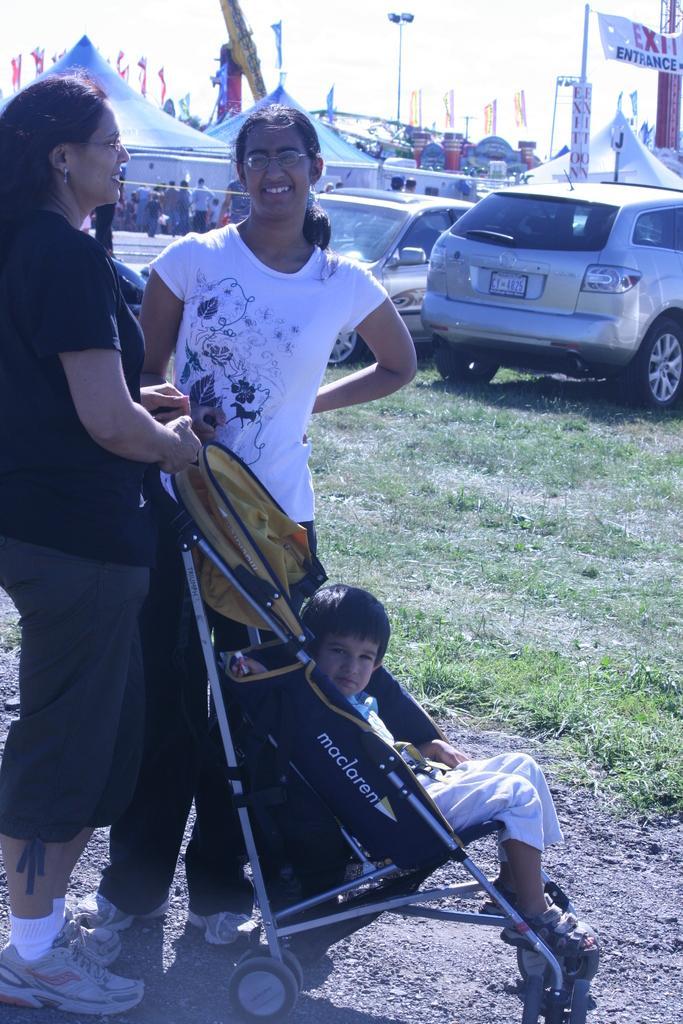Can you describe this image briefly? In this picture we can see a woman holding a baby carrier. We can see a child in this baby carrier. A person is standing on the path. Some grass is visible on the ground. We can see few tents, streetlights and some people are visible in the background. A banner on the poles is seen on the right side. 